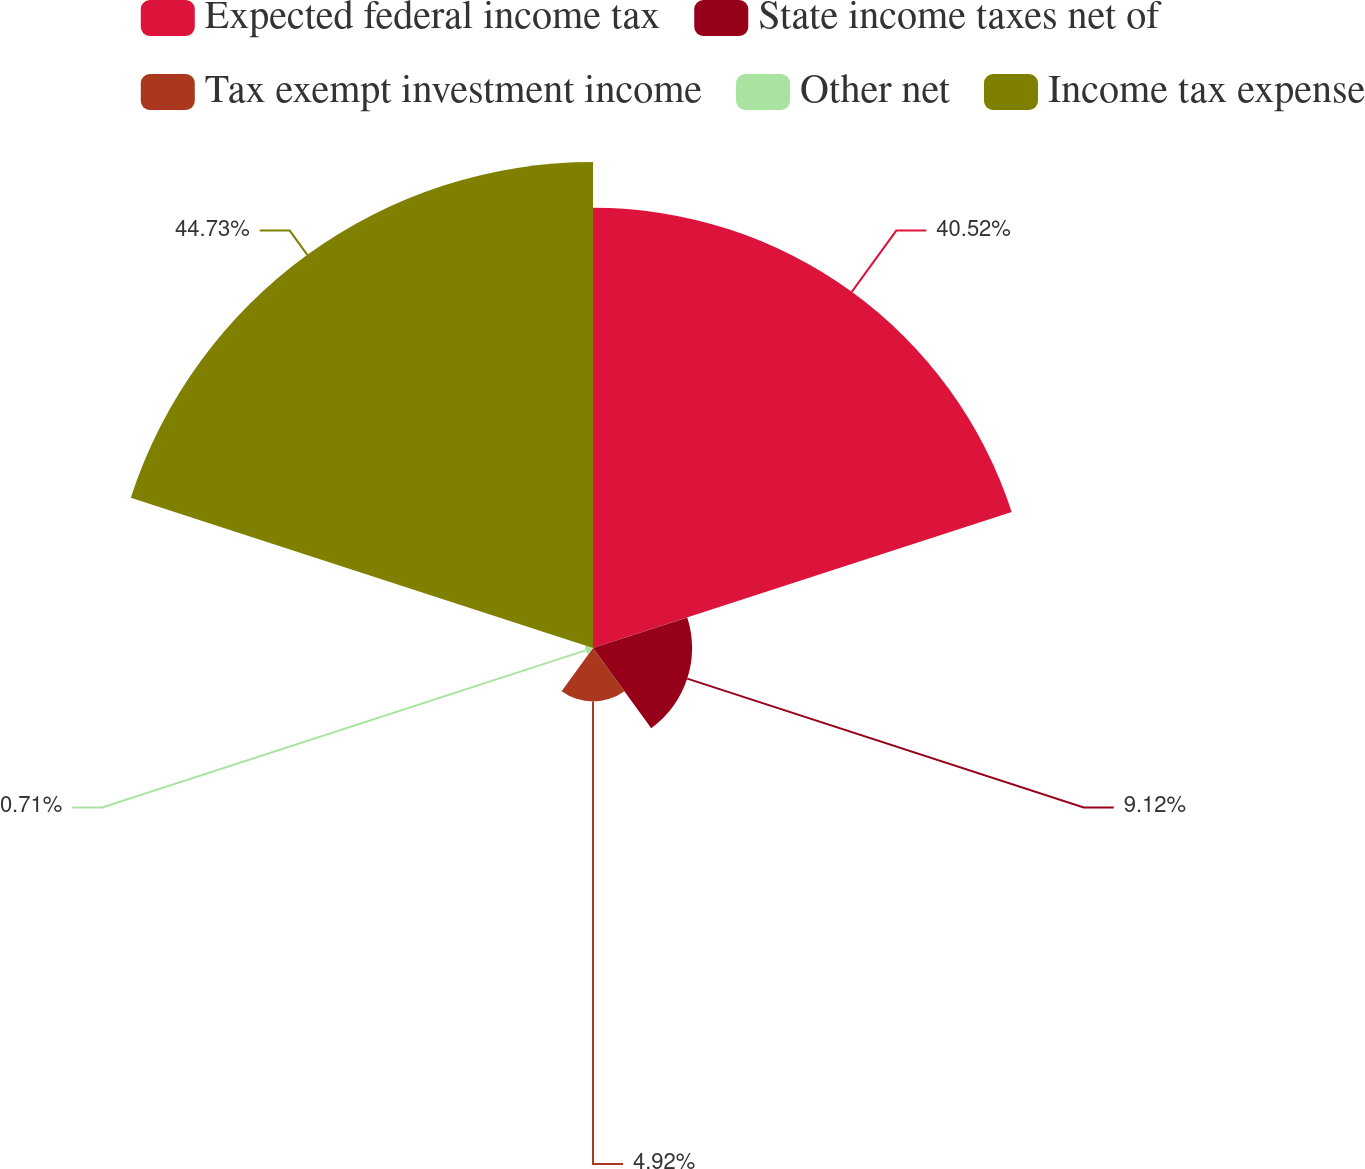<chart> <loc_0><loc_0><loc_500><loc_500><pie_chart><fcel>Expected federal income tax<fcel>State income taxes net of<fcel>Tax exempt investment income<fcel>Other net<fcel>Income tax expense<nl><fcel>40.52%<fcel>9.12%<fcel>4.92%<fcel>0.71%<fcel>44.73%<nl></chart> 